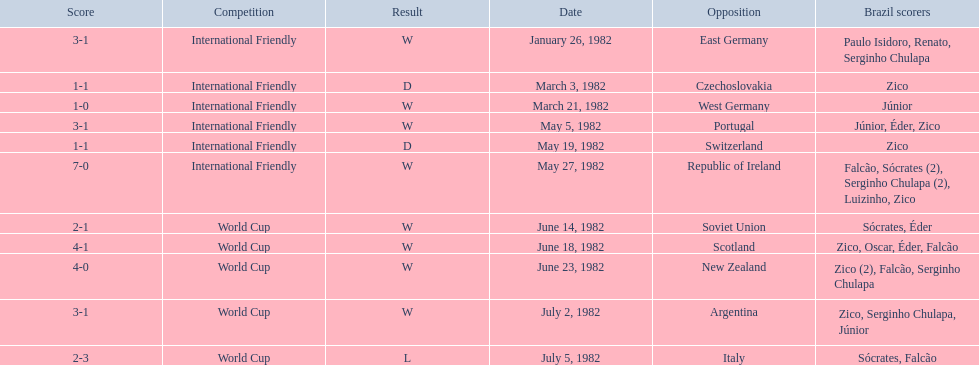What were the scores of each of game in the 1982 brazilian football games? 3-1, 1-1, 1-0, 3-1, 1-1, 7-0, 2-1, 4-1, 4-0, 3-1, 2-3. Of those, which were scores from games against portugal and the soviet union? 3-1, 2-1. And between those two games, against which country did brazil score more goals? Portugal. 